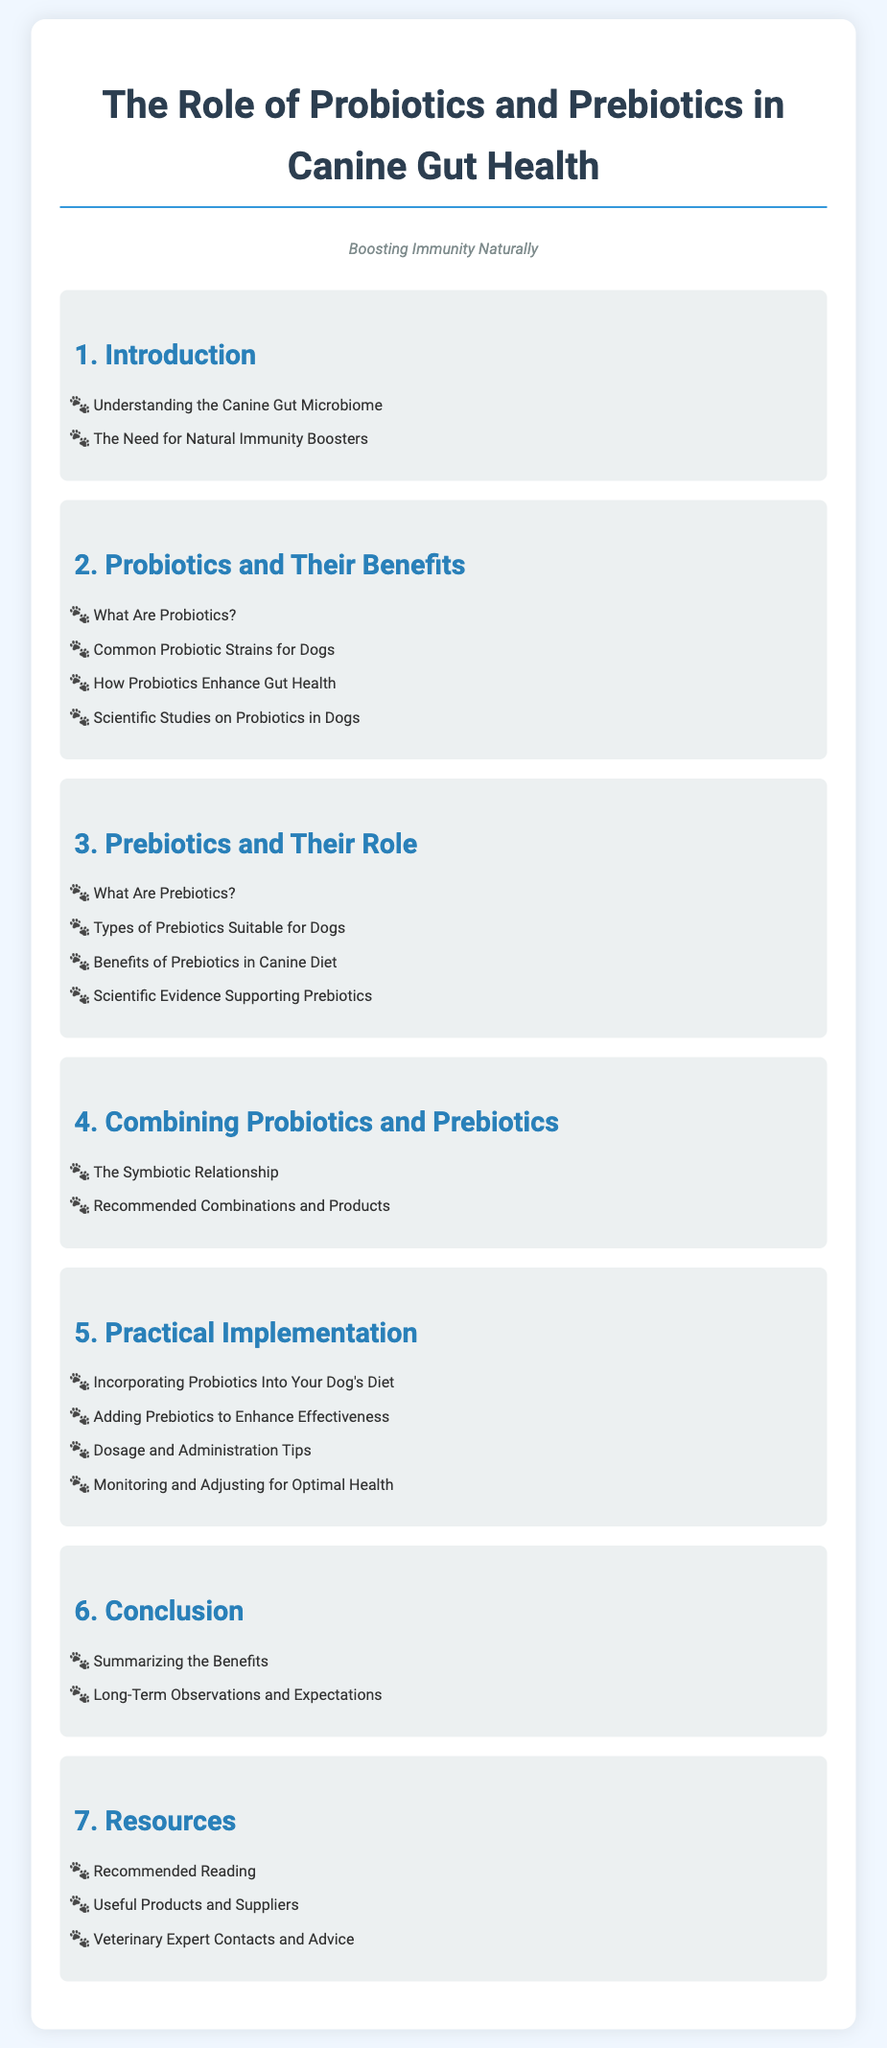What are prebiotics? Prebiotics are substances that provide nourishment to the beneficial bacteria in the gut.
Answer: Substances that provide nourishment to beneficial bacteria What section discusses probiotics? The section titled "Probiotics and Their Benefits" addresses information about probiotics.
Answer: Probiotics and Their Benefits How many main sections are in the document? The document contains seven main sections that cover various aspects of canine gut health.
Answer: Seven What is one benefit of prebiotics? Prebiotics help enhance the gut health of dogs by supporting the growth of good bacteria.
Answer: Enhance gut health What is a recommended action for pet owners regarding probiotics? Pet owners are advised to incorporate probiotics into their dog's diet to improve gut health.
Answer: Incorporate into diet What is the title of the document? The document is titled "The Role of Probiotics and Prebiotics in Canine Gut Health: Boosting Immunity Naturally."
Answer: The Role of Probiotics and Prebiotics in Canine Gut Health: Boosting Immunity Naturally What should be monitored for optimal health? Pet owners should monitor and adjust their dog's diet and usage of probiotics and prebiotics for optimal health benefits.
Answer: Monitoring and adjusting What does the section "Conclusion" summarize? The section "Conclusion" summarizes the benefits and provides insights into long-term observations and expectations.
Answer: Summarizing the benefits 